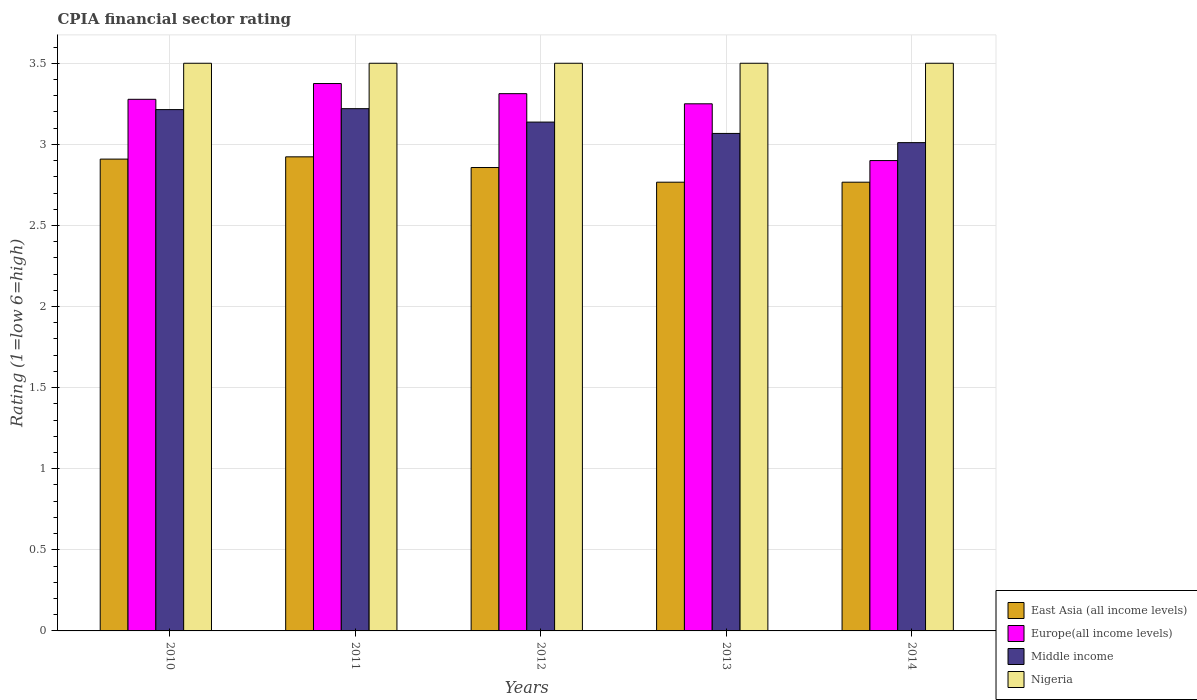How many different coloured bars are there?
Your response must be concise. 4. Are the number of bars per tick equal to the number of legend labels?
Keep it short and to the point. Yes. Are the number of bars on each tick of the X-axis equal?
Provide a succinct answer. Yes. How many bars are there on the 3rd tick from the right?
Provide a succinct answer. 4. In how many cases, is the number of bars for a given year not equal to the number of legend labels?
Offer a very short reply. 0. Across all years, what is the maximum CPIA rating in Middle income?
Make the answer very short. 3.22. Across all years, what is the minimum CPIA rating in Middle income?
Your answer should be very brief. 3.01. In which year was the CPIA rating in Europe(all income levels) maximum?
Make the answer very short. 2011. What is the total CPIA rating in Europe(all income levels) in the graph?
Offer a very short reply. 16.12. What is the difference between the CPIA rating in Middle income in 2012 and that in 2014?
Give a very brief answer. 0.13. What is the difference between the CPIA rating in Middle income in 2011 and the CPIA rating in East Asia (all income levels) in 2012?
Your answer should be very brief. 0.36. In the year 2011, what is the difference between the CPIA rating in Nigeria and CPIA rating in Middle income?
Provide a succinct answer. 0.28. What is the ratio of the CPIA rating in Middle income in 2010 to that in 2014?
Give a very brief answer. 1.07. Is the CPIA rating in Nigeria in 2012 less than that in 2014?
Ensure brevity in your answer.  No. What is the difference between the highest and the second highest CPIA rating in Europe(all income levels)?
Provide a short and direct response. 0.06. Is it the case that in every year, the sum of the CPIA rating in Europe(all income levels) and CPIA rating in Middle income is greater than the sum of CPIA rating in Nigeria and CPIA rating in East Asia (all income levels)?
Keep it short and to the point. No. What does the 1st bar from the left in 2012 represents?
Your response must be concise. East Asia (all income levels). What does the 3rd bar from the right in 2012 represents?
Provide a succinct answer. Europe(all income levels). How many bars are there?
Offer a very short reply. 20. Are all the bars in the graph horizontal?
Your answer should be compact. No. How many years are there in the graph?
Your answer should be compact. 5. Does the graph contain grids?
Provide a succinct answer. Yes. Where does the legend appear in the graph?
Your answer should be very brief. Bottom right. How many legend labels are there?
Provide a short and direct response. 4. How are the legend labels stacked?
Keep it short and to the point. Vertical. What is the title of the graph?
Make the answer very short. CPIA financial sector rating. Does "Egypt, Arab Rep." appear as one of the legend labels in the graph?
Provide a succinct answer. No. What is the label or title of the Y-axis?
Your response must be concise. Rating (1=low 6=high). What is the Rating (1=low 6=high) in East Asia (all income levels) in 2010?
Provide a succinct answer. 2.91. What is the Rating (1=low 6=high) of Europe(all income levels) in 2010?
Keep it short and to the point. 3.28. What is the Rating (1=low 6=high) of Middle income in 2010?
Ensure brevity in your answer.  3.21. What is the Rating (1=low 6=high) of East Asia (all income levels) in 2011?
Give a very brief answer. 2.92. What is the Rating (1=low 6=high) of Europe(all income levels) in 2011?
Make the answer very short. 3.38. What is the Rating (1=low 6=high) of Middle income in 2011?
Offer a very short reply. 3.22. What is the Rating (1=low 6=high) in East Asia (all income levels) in 2012?
Ensure brevity in your answer.  2.86. What is the Rating (1=low 6=high) in Europe(all income levels) in 2012?
Your answer should be compact. 3.31. What is the Rating (1=low 6=high) in Middle income in 2012?
Ensure brevity in your answer.  3.14. What is the Rating (1=low 6=high) of Nigeria in 2012?
Offer a very short reply. 3.5. What is the Rating (1=low 6=high) in East Asia (all income levels) in 2013?
Ensure brevity in your answer.  2.77. What is the Rating (1=low 6=high) of Middle income in 2013?
Your answer should be compact. 3.07. What is the Rating (1=low 6=high) in East Asia (all income levels) in 2014?
Your answer should be compact. 2.77. What is the Rating (1=low 6=high) of Middle income in 2014?
Provide a succinct answer. 3.01. Across all years, what is the maximum Rating (1=low 6=high) of East Asia (all income levels)?
Offer a terse response. 2.92. Across all years, what is the maximum Rating (1=low 6=high) of Europe(all income levels)?
Provide a short and direct response. 3.38. Across all years, what is the maximum Rating (1=low 6=high) in Middle income?
Offer a very short reply. 3.22. Across all years, what is the maximum Rating (1=low 6=high) of Nigeria?
Make the answer very short. 3.5. Across all years, what is the minimum Rating (1=low 6=high) in East Asia (all income levels)?
Offer a terse response. 2.77. Across all years, what is the minimum Rating (1=low 6=high) of Middle income?
Your answer should be very brief. 3.01. What is the total Rating (1=low 6=high) in East Asia (all income levels) in the graph?
Keep it short and to the point. 14.22. What is the total Rating (1=low 6=high) in Europe(all income levels) in the graph?
Offer a very short reply. 16.12. What is the total Rating (1=low 6=high) of Middle income in the graph?
Your response must be concise. 15.65. What is the difference between the Rating (1=low 6=high) of East Asia (all income levels) in 2010 and that in 2011?
Your response must be concise. -0.01. What is the difference between the Rating (1=low 6=high) in Europe(all income levels) in 2010 and that in 2011?
Ensure brevity in your answer.  -0.1. What is the difference between the Rating (1=low 6=high) of Middle income in 2010 and that in 2011?
Your response must be concise. -0.01. What is the difference between the Rating (1=low 6=high) of East Asia (all income levels) in 2010 and that in 2012?
Keep it short and to the point. 0.05. What is the difference between the Rating (1=low 6=high) of Europe(all income levels) in 2010 and that in 2012?
Keep it short and to the point. -0.03. What is the difference between the Rating (1=low 6=high) of Middle income in 2010 and that in 2012?
Provide a short and direct response. 0.08. What is the difference between the Rating (1=low 6=high) in Nigeria in 2010 and that in 2012?
Make the answer very short. 0. What is the difference between the Rating (1=low 6=high) in East Asia (all income levels) in 2010 and that in 2013?
Your response must be concise. 0.14. What is the difference between the Rating (1=low 6=high) in Europe(all income levels) in 2010 and that in 2013?
Your answer should be compact. 0.03. What is the difference between the Rating (1=low 6=high) of Middle income in 2010 and that in 2013?
Ensure brevity in your answer.  0.15. What is the difference between the Rating (1=low 6=high) in East Asia (all income levels) in 2010 and that in 2014?
Your response must be concise. 0.14. What is the difference between the Rating (1=low 6=high) in Europe(all income levels) in 2010 and that in 2014?
Ensure brevity in your answer.  0.38. What is the difference between the Rating (1=low 6=high) of Middle income in 2010 and that in 2014?
Give a very brief answer. 0.2. What is the difference between the Rating (1=low 6=high) in Nigeria in 2010 and that in 2014?
Ensure brevity in your answer.  0. What is the difference between the Rating (1=low 6=high) of East Asia (all income levels) in 2011 and that in 2012?
Give a very brief answer. 0.07. What is the difference between the Rating (1=low 6=high) of Europe(all income levels) in 2011 and that in 2012?
Provide a succinct answer. 0.06. What is the difference between the Rating (1=low 6=high) in Middle income in 2011 and that in 2012?
Keep it short and to the point. 0.08. What is the difference between the Rating (1=low 6=high) of Nigeria in 2011 and that in 2012?
Your answer should be very brief. 0. What is the difference between the Rating (1=low 6=high) in East Asia (all income levels) in 2011 and that in 2013?
Offer a terse response. 0.16. What is the difference between the Rating (1=low 6=high) in Middle income in 2011 and that in 2013?
Provide a succinct answer. 0.15. What is the difference between the Rating (1=low 6=high) in East Asia (all income levels) in 2011 and that in 2014?
Make the answer very short. 0.16. What is the difference between the Rating (1=low 6=high) of Europe(all income levels) in 2011 and that in 2014?
Offer a terse response. 0.47. What is the difference between the Rating (1=low 6=high) of Middle income in 2011 and that in 2014?
Provide a short and direct response. 0.21. What is the difference between the Rating (1=low 6=high) in East Asia (all income levels) in 2012 and that in 2013?
Your response must be concise. 0.09. What is the difference between the Rating (1=low 6=high) in Europe(all income levels) in 2012 and that in 2013?
Make the answer very short. 0.06. What is the difference between the Rating (1=low 6=high) in Middle income in 2012 and that in 2013?
Ensure brevity in your answer.  0.07. What is the difference between the Rating (1=low 6=high) in Nigeria in 2012 and that in 2013?
Provide a short and direct response. 0. What is the difference between the Rating (1=low 6=high) in East Asia (all income levels) in 2012 and that in 2014?
Your answer should be compact. 0.09. What is the difference between the Rating (1=low 6=high) of Europe(all income levels) in 2012 and that in 2014?
Provide a short and direct response. 0.41. What is the difference between the Rating (1=low 6=high) in Middle income in 2012 and that in 2014?
Your response must be concise. 0.13. What is the difference between the Rating (1=low 6=high) in Nigeria in 2012 and that in 2014?
Offer a very short reply. 0. What is the difference between the Rating (1=low 6=high) in East Asia (all income levels) in 2013 and that in 2014?
Give a very brief answer. 0. What is the difference between the Rating (1=low 6=high) of Europe(all income levels) in 2013 and that in 2014?
Provide a short and direct response. 0.35. What is the difference between the Rating (1=low 6=high) of Middle income in 2013 and that in 2014?
Your answer should be compact. 0.06. What is the difference between the Rating (1=low 6=high) of East Asia (all income levels) in 2010 and the Rating (1=low 6=high) of Europe(all income levels) in 2011?
Offer a very short reply. -0.47. What is the difference between the Rating (1=low 6=high) of East Asia (all income levels) in 2010 and the Rating (1=low 6=high) of Middle income in 2011?
Your response must be concise. -0.31. What is the difference between the Rating (1=low 6=high) in East Asia (all income levels) in 2010 and the Rating (1=low 6=high) in Nigeria in 2011?
Make the answer very short. -0.59. What is the difference between the Rating (1=low 6=high) in Europe(all income levels) in 2010 and the Rating (1=low 6=high) in Middle income in 2011?
Make the answer very short. 0.06. What is the difference between the Rating (1=low 6=high) in Europe(all income levels) in 2010 and the Rating (1=low 6=high) in Nigeria in 2011?
Make the answer very short. -0.22. What is the difference between the Rating (1=low 6=high) in Middle income in 2010 and the Rating (1=low 6=high) in Nigeria in 2011?
Offer a terse response. -0.29. What is the difference between the Rating (1=low 6=high) in East Asia (all income levels) in 2010 and the Rating (1=low 6=high) in Europe(all income levels) in 2012?
Your answer should be compact. -0.4. What is the difference between the Rating (1=low 6=high) of East Asia (all income levels) in 2010 and the Rating (1=low 6=high) of Middle income in 2012?
Your answer should be compact. -0.23. What is the difference between the Rating (1=low 6=high) in East Asia (all income levels) in 2010 and the Rating (1=low 6=high) in Nigeria in 2012?
Offer a very short reply. -0.59. What is the difference between the Rating (1=low 6=high) of Europe(all income levels) in 2010 and the Rating (1=low 6=high) of Middle income in 2012?
Keep it short and to the point. 0.14. What is the difference between the Rating (1=low 6=high) in Europe(all income levels) in 2010 and the Rating (1=low 6=high) in Nigeria in 2012?
Offer a terse response. -0.22. What is the difference between the Rating (1=low 6=high) in Middle income in 2010 and the Rating (1=low 6=high) in Nigeria in 2012?
Your answer should be compact. -0.29. What is the difference between the Rating (1=low 6=high) of East Asia (all income levels) in 2010 and the Rating (1=low 6=high) of Europe(all income levels) in 2013?
Offer a very short reply. -0.34. What is the difference between the Rating (1=low 6=high) in East Asia (all income levels) in 2010 and the Rating (1=low 6=high) in Middle income in 2013?
Give a very brief answer. -0.16. What is the difference between the Rating (1=low 6=high) of East Asia (all income levels) in 2010 and the Rating (1=low 6=high) of Nigeria in 2013?
Offer a very short reply. -0.59. What is the difference between the Rating (1=low 6=high) of Europe(all income levels) in 2010 and the Rating (1=low 6=high) of Middle income in 2013?
Provide a succinct answer. 0.21. What is the difference between the Rating (1=low 6=high) of Europe(all income levels) in 2010 and the Rating (1=low 6=high) of Nigeria in 2013?
Give a very brief answer. -0.22. What is the difference between the Rating (1=low 6=high) of Middle income in 2010 and the Rating (1=low 6=high) of Nigeria in 2013?
Provide a succinct answer. -0.29. What is the difference between the Rating (1=low 6=high) in East Asia (all income levels) in 2010 and the Rating (1=low 6=high) in Europe(all income levels) in 2014?
Keep it short and to the point. 0.01. What is the difference between the Rating (1=low 6=high) in East Asia (all income levels) in 2010 and the Rating (1=low 6=high) in Middle income in 2014?
Your answer should be compact. -0.1. What is the difference between the Rating (1=low 6=high) of East Asia (all income levels) in 2010 and the Rating (1=low 6=high) of Nigeria in 2014?
Your answer should be very brief. -0.59. What is the difference between the Rating (1=low 6=high) of Europe(all income levels) in 2010 and the Rating (1=low 6=high) of Middle income in 2014?
Your answer should be very brief. 0.27. What is the difference between the Rating (1=low 6=high) in Europe(all income levels) in 2010 and the Rating (1=low 6=high) in Nigeria in 2014?
Provide a succinct answer. -0.22. What is the difference between the Rating (1=low 6=high) of Middle income in 2010 and the Rating (1=low 6=high) of Nigeria in 2014?
Offer a very short reply. -0.29. What is the difference between the Rating (1=low 6=high) in East Asia (all income levels) in 2011 and the Rating (1=low 6=high) in Europe(all income levels) in 2012?
Your answer should be compact. -0.39. What is the difference between the Rating (1=low 6=high) in East Asia (all income levels) in 2011 and the Rating (1=low 6=high) in Middle income in 2012?
Provide a short and direct response. -0.21. What is the difference between the Rating (1=low 6=high) in East Asia (all income levels) in 2011 and the Rating (1=low 6=high) in Nigeria in 2012?
Your answer should be compact. -0.58. What is the difference between the Rating (1=low 6=high) in Europe(all income levels) in 2011 and the Rating (1=low 6=high) in Middle income in 2012?
Your response must be concise. 0.24. What is the difference between the Rating (1=low 6=high) in Europe(all income levels) in 2011 and the Rating (1=low 6=high) in Nigeria in 2012?
Give a very brief answer. -0.12. What is the difference between the Rating (1=low 6=high) in Middle income in 2011 and the Rating (1=low 6=high) in Nigeria in 2012?
Provide a succinct answer. -0.28. What is the difference between the Rating (1=low 6=high) in East Asia (all income levels) in 2011 and the Rating (1=low 6=high) in Europe(all income levels) in 2013?
Your response must be concise. -0.33. What is the difference between the Rating (1=low 6=high) of East Asia (all income levels) in 2011 and the Rating (1=low 6=high) of Middle income in 2013?
Provide a succinct answer. -0.14. What is the difference between the Rating (1=low 6=high) of East Asia (all income levels) in 2011 and the Rating (1=low 6=high) of Nigeria in 2013?
Provide a succinct answer. -0.58. What is the difference between the Rating (1=low 6=high) of Europe(all income levels) in 2011 and the Rating (1=low 6=high) of Middle income in 2013?
Offer a terse response. 0.31. What is the difference between the Rating (1=low 6=high) in Europe(all income levels) in 2011 and the Rating (1=low 6=high) in Nigeria in 2013?
Your response must be concise. -0.12. What is the difference between the Rating (1=low 6=high) of Middle income in 2011 and the Rating (1=low 6=high) of Nigeria in 2013?
Your answer should be compact. -0.28. What is the difference between the Rating (1=low 6=high) in East Asia (all income levels) in 2011 and the Rating (1=low 6=high) in Europe(all income levels) in 2014?
Your answer should be very brief. 0.02. What is the difference between the Rating (1=low 6=high) in East Asia (all income levels) in 2011 and the Rating (1=low 6=high) in Middle income in 2014?
Keep it short and to the point. -0.09. What is the difference between the Rating (1=low 6=high) of East Asia (all income levels) in 2011 and the Rating (1=low 6=high) of Nigeria in 2014?
Provide a succinct answer. -0.58. What is the difference between the Rating (1=low 6=high) of Europe(all income levels) in 2011 and the Rating (1=low 6=high) of Middle income in 2014?
Provide a short and direct response. 0.36. What is the difference between the Rating (1=low 6=high) of Europe(all income levels) in 2011 and the Rating (1=low 6=high) of Nigeria in 2014?
Provide a succinct answer. -0.12. What is the difference between the Rating (1=low 6=high) of Middle income in 2011 and the Rating (1=low 6=high) of Nigeria in 2014?
Your answer should be very brief. -0.28. What is the difference between the Rating (1=low 6=high) in East Asia (all income levels) in 2012 and the Rating (1=low 6=high) in Europe(all income levels) in 2013?
Your answer should be compact. -0.39. What is the difference between the Rating (1=low 6=high) of East Asia (all income levels) in 2012 and the Rating (1=low 6=high) of Middle income in 2013?
Give a very brief answer. -0.21. What is the difference between the Rating (1=low 6=high) of East Asia (all income levels) in 2012 and the Rating (1=low 6=high) of Nigeria in 2013?
Provide a succinct answer. -0.64. What is the difference between the Rating (1=low 6=high) in Europe(all income levels) in 2012 and the Rating (1=low 6=high) in Middle income in 2013?
Keep it short and to the point. 0.25. What is the difference between the Rating (1=low 6=high) in Europe(all income levels) in 2012 and the Rating (1=low 6=high) in Nigeria in 2013?
Keep it short and to the point. -0.19. What is the difference between the Rating (1=low 6=high) of Middle income in 2012 and the Rating (1=low 6=high) of Nigeria in 2013?
Your answer should be very brief. -0.36. What is the difference between the Rating (1=low 6=high) of East Asia (all income levels) in 2012 and the Rating (1=low 6=high) of Europe(all income levels) in 2014?
Keep it short and to the point. -0.04. What is the difference between the Rating (1=low 6=high) in East Asia (all income levels) in 2012 and the Rating (1=low 6=high) in Middle income in 2014?
Your response must be concise. -0.15. What is the difference between the Rating (1=low 6=high) of East Asia (all income levels) in 2012 and the Rating (1=low 6=high) of Nigeria in 2014?
Offer a very short reply. -0.64. What is the difference between the Rating (1=low 6=high) in Europe(all income levels) in 2012 and the Rating (1=low 6=high) in Middle income in 2014?
Your response must be concise. 0.3. What is the difference between the Rating (1=low 6=high) of Europe(all income levels) in 2012 and the Rating (1=low 6=high) of Nigeria in 2014?
Your answer should be very brief. -0.19. What is the difference between the Rating (1=low 6=high) of Middle income in 2012 and the Rating (1=low 6=high) of Nigeria in 2014?
Ensure brevity in your answer.  -0.36. What is the difference between the Rating (1=low 6=high) in East Asia (all income levels) in 2013 and the Rating (1=low 6=high) in Europe(all income levels) in 2014?
Offer a terse response. -0.13. What is the difference between the Rating (1=low 6=high) of East Asia (all income levels) in 2013 and the Rating (1=low 6=high) of Middle income in 2014?
Offer a terse response. -0.24. What is the difference between the Rating (1=low 6=high) in East Asia (all income levels) in 2013 and the Rating (1=low 6=high) in Nigeria in 2014?
Ensure brevity in your answer.  -0.73. What is the difference between the Rating (1=low 6=high) in Europe(all income levels) in 2013 and the Rating (1=low 6=high) in Middle income in 2014?
Make the answer very short. 0.24. What is the difference between the Rating (1=low 6=high) of Europe(all income levels) in 2013 and the Rating (1=low 6=high) of Nigeria in 2014?
Your response must be concise. -0.25. What is the difference between the Rating (1=low 6=high) in Middle income in 2013 and the Rating (1=low 6=high) in Nigeria in 2014?
Offer a very short reply. -0.43. What is the average Rating (1=low 6=high) in East Asia (all income levels) per year?
Provide a short and direct response. 2.84. What is the average Rating (1=low 6=high) in Europe(all income levels) per year?
Offer a terse response. 3.22. What is the average Rating (1=low 6=high) of Middle income per year?
Offer a terse response. 3.13. What is the average Rating (1=low 6=high) of Nigeria per year?
Make the answer very short. 3.5. In the year 2010, what is the difference between the Rating (1=low 6=high) in East Asia (all income levels) and Rating (1=low 6=high) in Europe(all income levels)?
Offer a terse response. -0.37. In the year 2010, what is the difference between the Rating (1=low 6=high) in East Asia (all income levels) and Rating (1=low 6=high) in Middle income?
Offer a terse response. -0.31. In the year 2010, what is the difference between the Rating (1=low 6=high) in East Asia (all income levels) and Rating (1=low 6=high) in Nigeria?
Ensure brevity in your answer.  -0.59. In the year 2010, what is the difference between the Rating (1=low 6=high) in Europe(all income levels) and Rating (1=low 6=high) in Middle income?
Offer a very short reply. 0.06. In the year 2010, what is the difference between the Rating (1=low 6=high) of Europe(all income levels) and Rating (1=low 6=high) of Nigeria?
Your answer should be very brief. -0.22. In the year 2010, what is the difference between the Rating (1=low 6=high) of Middle income and Rating (1=low 6=high) of Nigeria?
Ensure brevity in your answer.  -0.29. In the year 2011, what is the difference between the Rating (1=low 6=high) of East Asia (all income levels) and Rating (1=low 6=high) of Europe(all income levels)?
Your answer should be compact. -0.45. In the year 2011, what is the difference between the Rating (1=low 6=high) of East Asia (all income levels) and Rating (1=low 6=high) of Middle income?
Ensure brevity in your answer.  -0.3. In the year 2011, what is the difference between the Rating (1=low 6=high) in East Asia (all income levels) and Rating (1=low 6=high) in Nigeria?
Ensure brevity in your answer.  -0.58. In the year 2011, what is the difference between the Rating (1=low 6=high) of Europe(all income levels) and Rating (1=low 6=high) of Middle income?
Provide a succinct answer. 0.15. In the year 2011, what is the difference between the Rating (1=low 6=high) of Europe(all income levels) and Rating (1=low 6=high) of Nigeria?
Your answer should be very brief. -0.12. In the year 2011, what is the difference between the Rating (1=low 6=high) in Middle income and Rating (1=low 6=high) in Nigeria?
Your answer should be very brief. -0.28. In the year 2012, what is the difference between the Rating (1=low 6=high) in East Asia (all income levels) and Rating (1=low 6=high) in Europe(all income levels)?
Keep it short and to the point. -0.46. In the year 2012, what is the difference between the Rating (1=low 6=high) of East Asia (all income levels) and Rating (1=low 6=high) of Middle income?
Make the answer very short. -0.28. In the year 2012, what is the difference between the Rating (1=low 6=high) of East Asia (all income levels) and Rating (1=low 6=high) of Nigeria?
Offer a terse response. -0.64. In the year 2012, what is the difference between the Rating (1=low 6=high) of Europe(all income levels) and Rating (1=low 6=high) of Middle income?
Offer a very short reply. 0.18. In the year 2012, what is the difference between the Rating (1=low 6=high) of Europe(all income levels) and Rating (1=low 6=high) of Nigeria?
Provide a succinct answer. -0.19. In the year 2012, what is the difference between the Rating (1=low 6=high) of Middle income and Rating (1=low 6=high) of Nigeria?
Keep it short and to the point. -0.36. In the year 2013, what is the difference between the Rating (1=low 6=high) in East Asia (all income levels) and Rating (1=low 6=high) in Europe(all income levels)?
Your answer should be compact. -0.48. In the year 2013, what is the difference between the Rating (1=low 6=high) in East Asia (all income levels) and Rating (1=low 6=high) in Middle income?
Ensure brevity in your answer.  -0.3. In the year 2013, what is the difference between the Rating (1=low 6=high) of East Asia (all income levels) and Rating (1=low 6=high) of Nigeria?
Your answer should be very brief. -0.73. In the year 2013, what is the difference between the Rating (1=low 6=high) of Europe(all income levels) and Rating (1=low 6=high) of Middle income?
Offer a terse response. 0.18. In the year 2013, what is the difference between the Rating (1=low 6=high) of Middle income and Rating (1=low 6=high) of Nigeria?
Make the answer very short. -0.43. In the year 2014, what is the difference between the Rating (1=low 6=high) in East Asia (all income levels) and Rating (1=low 6=high) in Europe(all income levels)?
Your answer should be very brief. -0.13. In the year 2014, what is the difference between the Rating (1=low 6=high) of East Asia (all income levels) and Rating (1=low 6=high) of Middle income?
Offer a terse response. -0.24. In the year 2014, what is the difference between the Rating (1=low 6=high) of East Asia (all income levels) and Rating (1=low 6=high) of Nigeria?
Your answer should be very brief. -0.73. In the year 2014, what is the difference between the Rating (1=low 6=high) in Europe(all income levels) and Rating (1=low 6=high) in Middle income?
Your answer should be very brief. -0.11. In the year 2014, what is the difference between the Rating (1=low 6=high) of Europe(all income levels) and Rating (1=low 6=high) of Nigeria?
Offer a terse response. -0.6. In the year 2014, what is the difference between the Rating (1=low 6=high) of Middle income and Rating (1=low 6=high) of Nigeria?
Give a very brief answer. -0.49. What is the ratio of the Rating (1=low 6=high) of Europe(all income levels) in 2010 to that in 2011?
Ensure brevity in your answer.  0.97. What is the ratio of the Rating (1=low 6=high) in Middle income in 2010 to that in 2011?
Make the answer very short. 1. What is the ratio of the Rating (1=low 6=high) of East Asia (all income levels) in 2010 to that in 2012?
Make the answer very short. 1.02. What is the ratio of the Rating (1=low 6=high) of Middle income in 2010 to that in 2012?
Provide a short and direct response. 1.02. What is the ratio of the Rating (1=low 6=high) in Nigeria in 2010 to that in 2012?
Provide a short and direct response. 1. What is the ratio of the Rating (1=low 6=high) of East Asia (all income levels) in 2010 to that in 2013?
Keep it short and to the point. 1.05. What is the ratio of the Rating (1=low 6=high) of Europe(all income levels) in 2010 to that in 2013?
Make the answer very short. 1.01. What is the ratio of the Rating (1=low 6=high) of Middle income in 2010 to that in 2013?
Your answer should be compact. 1.05. What is the ratio of the Rating (1=low 6=high) in Nigeria in 2010 to that in 2013?
Your answer should be very brief. 1. What is the ratio of the Rating (1=low 6=high) in East Asia (all income levels) in 2010 to that in 2014?
Offer a very short reply. 1.05. What is the ratio of the Rating (1=low 6=high) of Europe(all income levels) in 2010 to that in 2014?
Ensure brevity in your answer.  1.13. What is the ratio of the Rating (1=low 6=high) in Middle income in 2010 to that in 2014?
Ensure brevity in your answer.  1.07. What is the ratio of the Rating (1=low 6=high) in East Asia (all income levels) in 2011 to that in 2012?
Give a very brief answer. 1.02. What is the ratio of the Rating (1=low 6=high) of Europe(all income levels) in 2011 to that in 2012?
Ensure brevity in your answer.  1.02. What is the ratio of the Rating (1=low 6=high) of Middle income in 2011 to that in 2012?
Provide a short and direct response. 1.03. What is the ratio of the Rating (1=low 6=high) of East Asia (all income levels) in 2011 to that in 2013?
Your answer should be compact. 1.06. What is the ratio of the Rating (1=low 6=high) in Middle income in 2011 to that in 2013?
Offer a terse response. 1.05. What is the ratio of the Rating (1=low 6=high) of East Asia (all income levels) in 2011 to that in 2014?
Offer a very short reply. 1.06. What is the ratio of the Rating (1=low 6=high) of Europe(all income levels) in 2011 to that in 2014?
Offer a terse response. 1.16. What is the ratio of the Rating (1=low 6=high) of Middle income in 2011 to that in 2014?
Provide a short and direct response. 1.07. What is the ratio of the Rating (1=low 6=high) in East Asia (all income levels) in 2012 to that in 2013?
Give a very brief answer. 1.03. What is the ratio of the Rating (1=low 6=high) of Europe(all income levels) in 2012 to that in 2013?
Offer a very short reply. 1.02. What is the ratio of the Rating (1=low 6=high) of Middle income in 2012 to that in 2013?
Your answer should be very brief. 1.02. What is the ratio of the Rating (1=low 6=high) in Nigeria in 2012 to that in 2013?
Make the answer very short. 1. What is the ratio of the Rating (1=low 6=high) of East Asia (all income levels) in 2012 to that in 2014?
Keep it short and to the point. 1.03. What is the ratio of the Rating (1=low 6=high) in Europe(all income levels) in 2012 to that in 2014?
Provide a short and direct response. 1.14. What is the ratio of the Rating (1=low 6=high) in Middle income in 2012 to that in 2014?
Provide a succinct answer. 1.04. What is the ratio of the Rating (1=low 6=high) of Europe(all income levels) in 2013 to that in 2014?
Offer a very short reply. 1.12. What is the ratio of the Rating (1=low 6=high) of Middle income in 2013 to that in 2014?
Provide a succinct answer. 1.02. What is the difference between the highest and the second highest Rating (1=low 6=high) of East Asia (all income levels)?
Your answer should be compact. 0.01. What is the difference between the highest and the second highest Rating (1=low 6=high) of Europe(all income levels)?
Keep it short and to the point. 0.06. What is the difference between the highest and the second highest Rating (1=low 6=high) of Middle income?
Provide a succinct answer. 0.01. What is the difference between the highest and the second highest Rating (1=low 6=high) in Nigeria?
Your response must be concise. 0. What is the difference between the highest and the lowest Rating (1=low 6=high) in East Asia (all income levels)?
Offer a very short reply. 0.16. What is the difference between the highest and the lowest Rating (1=low 6=high) of Europe(all income levels)?
Offer a terse response. 0.47. What is the difference between the highest and the lowest Rating (1=low 6=high) in Middle income?
Your answer should be very brief. 0.21. What is the difference between the highest and the lowest Rating (1=low 6=high) in Nigeria?
Provide a short and direct response. 0. 